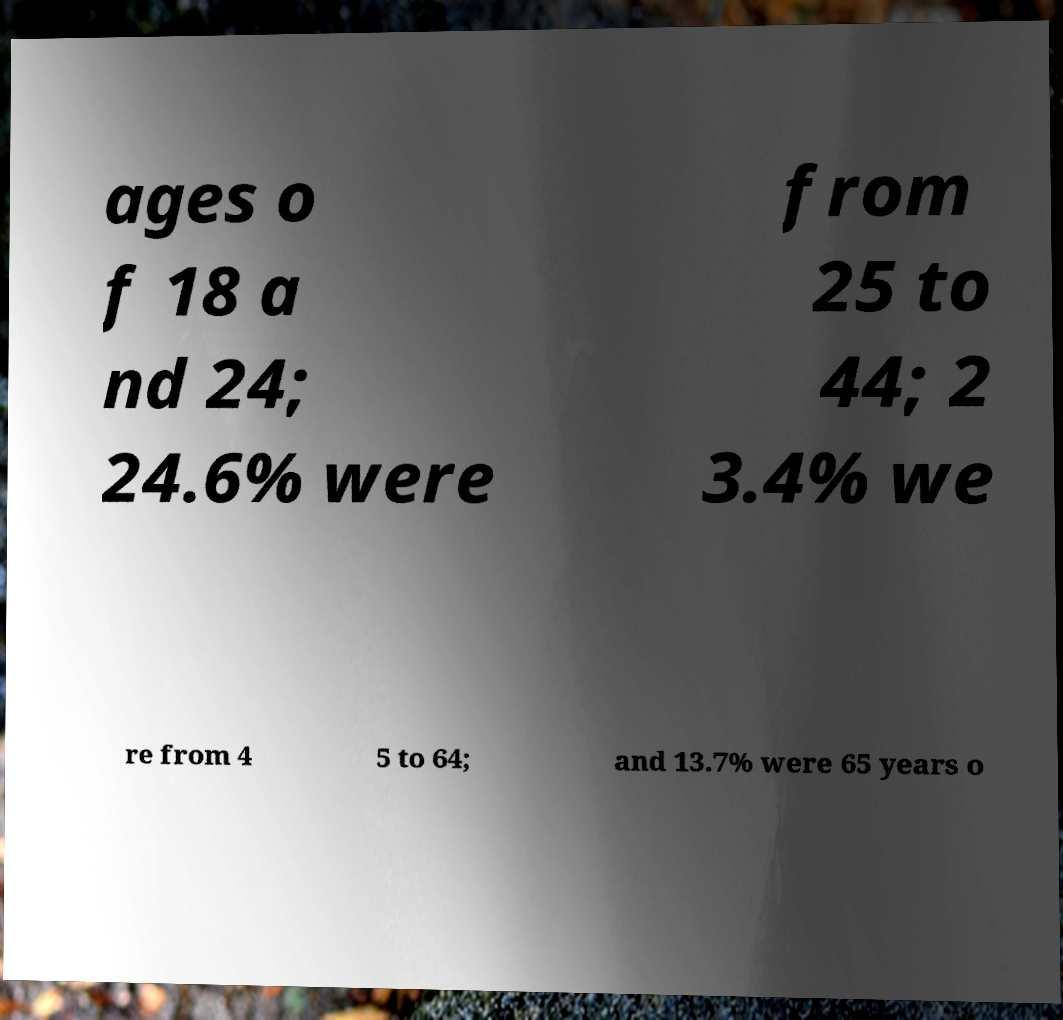Can you accurately transcribe the text from the provided image for me? ages o f 18 a nd 24; 24.6% were from 25 to 44; 2 3.4% we re from 4 5 to 64; and 13.7% were 65 years o 